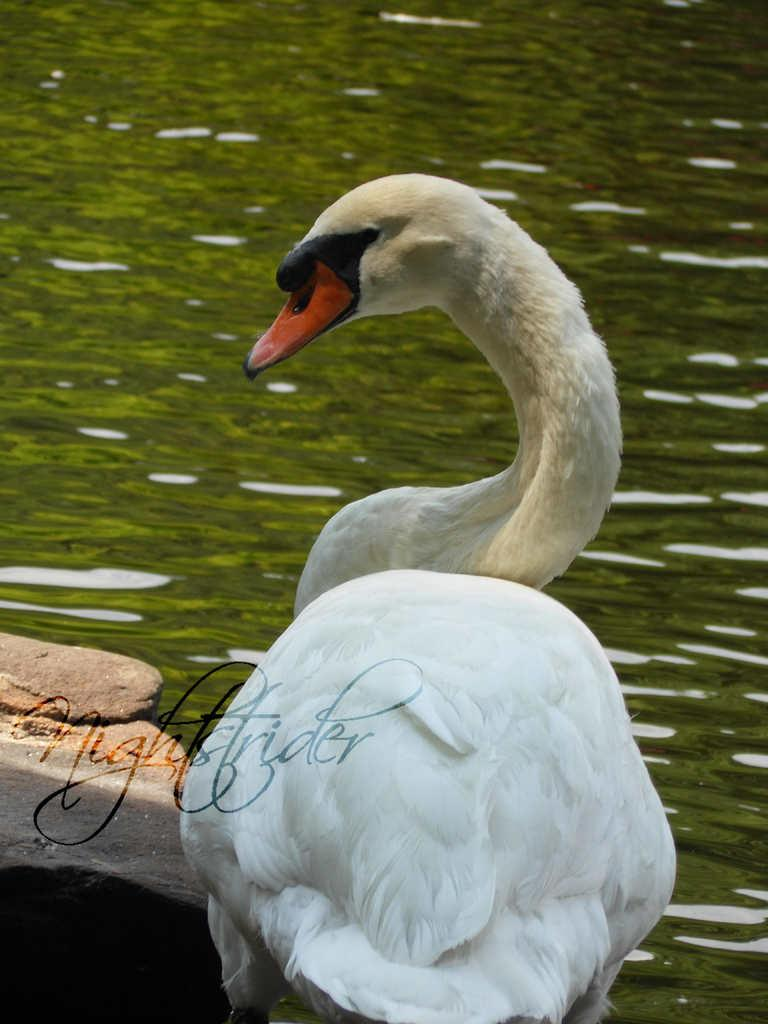What type of animal can be seen in the image? There is a bird in the image. What colors are present on the bird? The bird has white, black, and red colors. Where is the bird located in the image? The bird is on a rock. What else can be seen in the image besides the bird? There is water visible in the image. What type of basket is the goat carrying on its head in the image? There is no goat or basket present in the image; it features a bird on a rock with water visible. What type of crown is the queen wearing in the image? There is no queen or crown present in the image; it features a bird on a rock with water visible. 